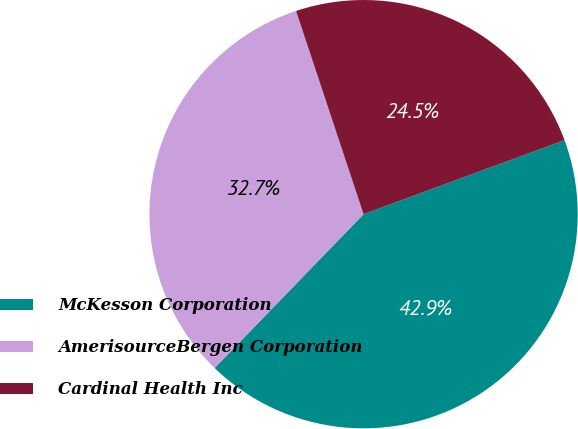<chart> <loc_0><loc_0><loc_500><loc_500><pie_chart><fcel>McKesson Corporation<fcel>AmerisourceBergen Corporation<fcel>Cardinal Health Inc<nl><fcel>42.86%<fcel>32.65%<fcel>24.49%<nl></chart> 